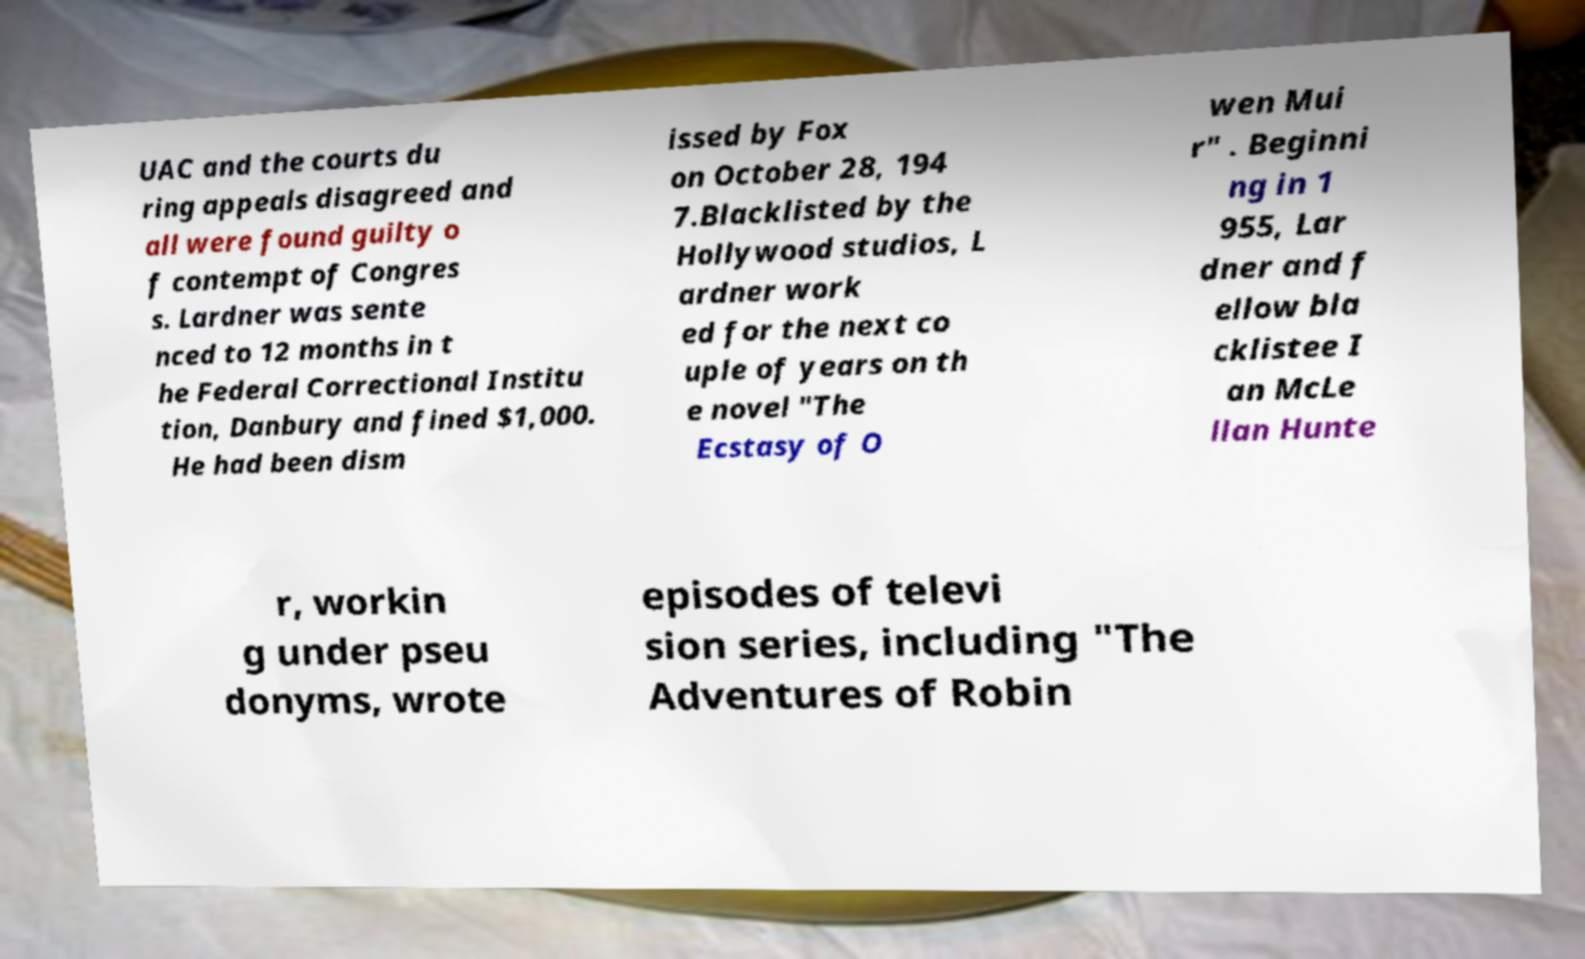There's text embedded in this image that I need extracted. Can you transcribe it verbatim? UAC and the courts du ring appeals disagreed and all were found guilty o f contempt of Congres s. Lardner was sente nced to 12 months in t he Federal Correctional Institu tion, Danbury and fined $1,000. He had been dism issed by Fox on October 28, 194 7.Blacklisted by the Hollywood studios, L ardner work ed for the next co uple of years on th e novel "The Ecstasy of O wen Mui r" . Beginni ng in 1 955, Lar dner and f ellow bla cklistee I an McLe llan Hunte r, workin g under pseu donyms, wrote episodes of televi sion series, including "The Adventures of Robin 